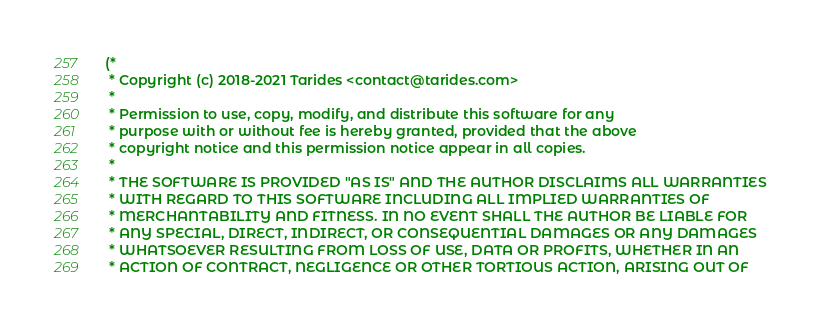Convert code to text. <code><loc_0><loc_0><loc_500><loc_500><_OCaml_>(*
 * Copyright (c) 2018-2021 Tarides <contact@tarides.com>
 *
 * Permission to use, copy, modify, and distribute this software for any
 * purpose with or without fee is hereby granted, provided that the above
 * copyright notice and this permission notice appear in all copies.
 *
 * THE SOFTWARE IS PROVIDED "AS IS" AND THE AUTHOR DISCLAIMS ALL WARRANTIES
 * WITH REGARD TO THIS SOFTWARE INCLUDING ALL IMPLIED WARRANTIES OF
 * MERCHANTABILITY AND FITNESS. IN NO EVENT SHALL THE AUTHOR BE LIABLE FOR
 * ANY SPECIAL, DIRECT, INDIRECT, OR CONSEQUENTIAL DAMAGES OR ANY DAMAGES
 * WHATSOEVER RESULTING FROM LOSS OF USE, DATA OR PROFITS, WHETHER IN AN
 * ACTION OF CONTRACT, NEGLIGENCE OR OTHER TORTIOUS ACTION, ARISING OUT OF</code> 